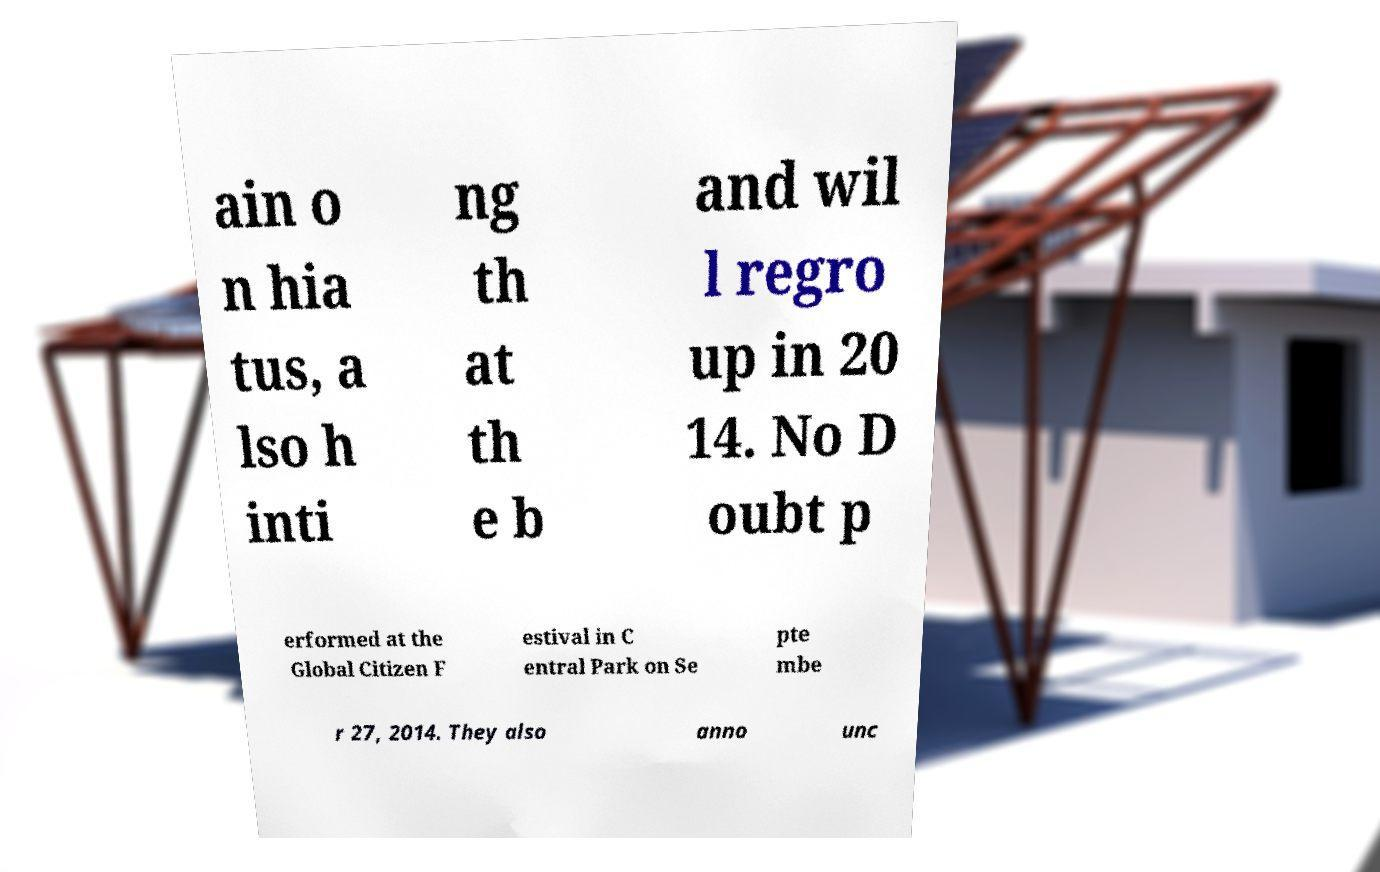Could you extract and type out the text from this image? ain o n hia tus, a lso h inti ng th at th e b and wil l regro up in 20 14. No D oubt p erformed at the Global Citizen F estival in C entral Park on Se pte mbe r 27, 2014. They also anno unc 